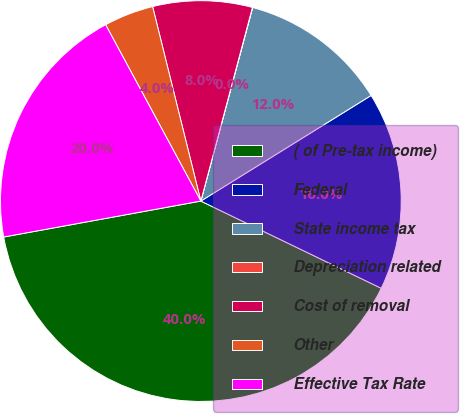<chart> <loc_0><loc_0><loc_500><loc_500><pie_chart><fcel>( of Pre-tax income)<fcel>Federal<fcel>State income tax<fcel>Depreciation related<fcel>Cost of removal<fcel>Other<fcel>Effective Tax Rate<nl><fcel>39.96%<fcel>16.0%<fcel>12.0%<fcel>0.02%<fcel>8.01%<fcel>4.01%<fcel>19.99%<nl></chart> 